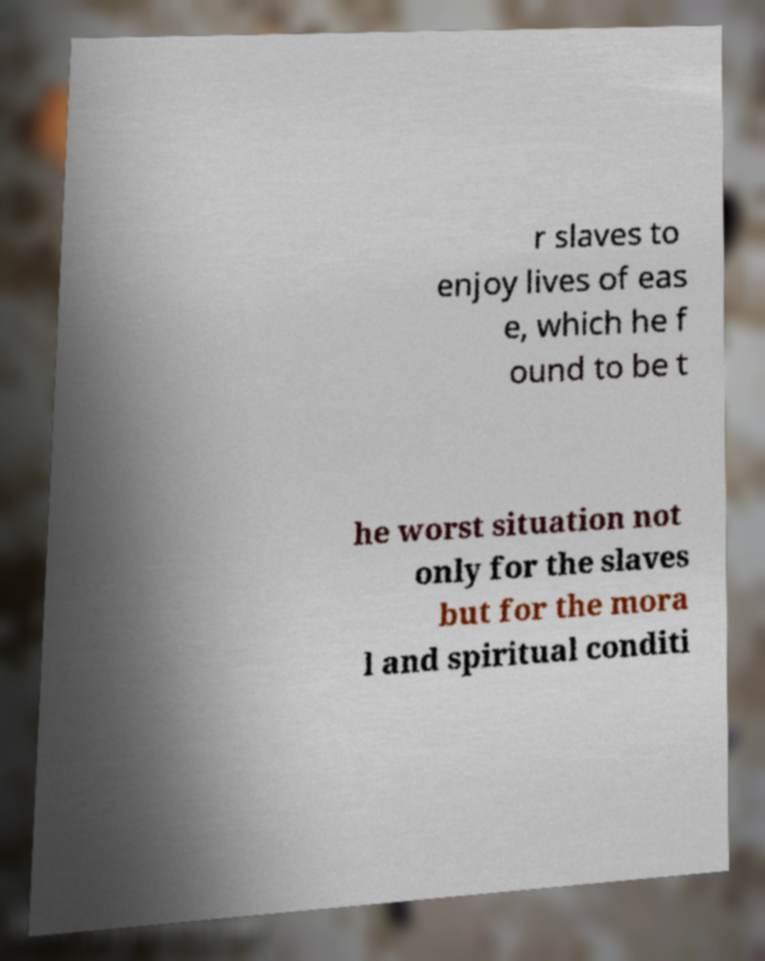What messages or text are displayed in this image? I need them in a readable, typed format. r slaves to enjoy lives of eas e, which he f ound to be t he worst situation not only for the slaves but for the mora l and spiritual conditi 